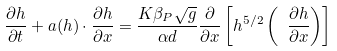<formula> <loc_0><loc_0><loc_500><loc_500>\frac { \partial h } { \partial t } + a ( h ) \cdot \frac { \partial h } { \partial x } = \frac { K \beta _ { P } \sqrt { g } } { \alpha d } \frac { \partial } { \partial x } \left [ h ^ { 5 / 2 } \left ( \ \frac { \partial h } { \partial x } \right ) \right ]</formula> 